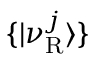<formula> <loc_0><loc_0><loc_500><loc_500>\{ | \nu _ { R } ^ { j } \rangle \}</formula> 